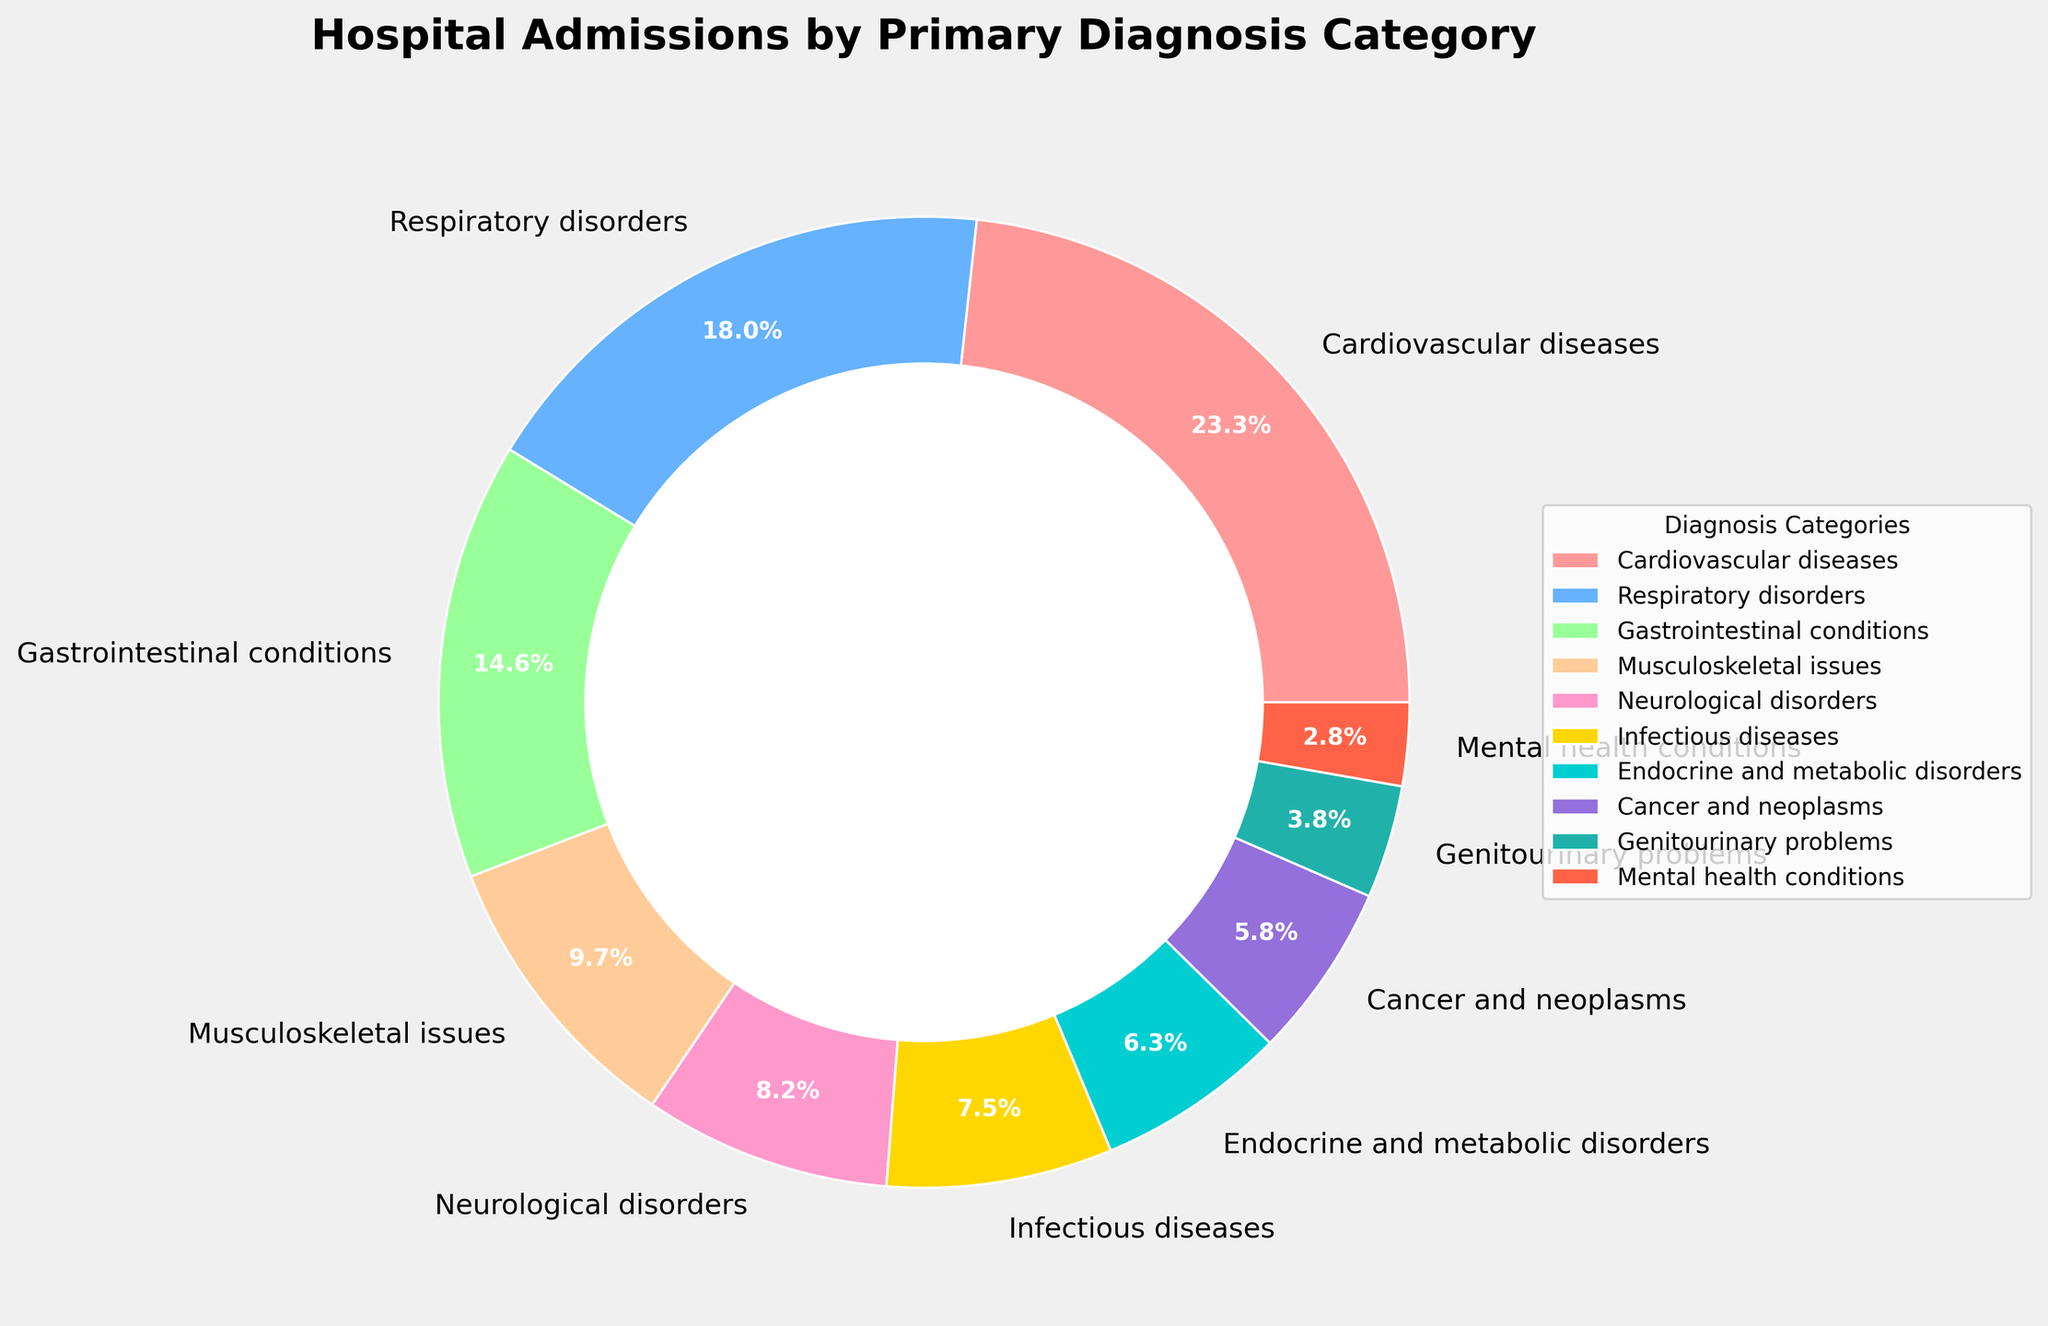Which category has the highest percentage of hospital admissions? The highest percentage is the one with the largest segment in the pie chart. According to the legend, cardiovascular diseases have the largest segment at 23.5%.
Answer: Cardiovascular diseases Which category has a smaller percentage: Mental health conditions or Genitourinary problems? By comparing the segments for Mental health conditions and Genitourinary problems, Mental health conditions have a smaller segment. According to the data, Mental health conditions have 2.8% while Genitourinary problems have 3.8%.
Answer: Mental health conditions How does the percentage of hospital admissions for Respiratory disorders compare to that for Gastrointestinal conditions? By comparing the segments, Respiratory disorders have a larger segment than Gastrointestinal conditions. The percentages are 18.2% for Respiratory disorders and 14.7% for Gastrointestinal conditions.
Answer: Respiratory disorders are higher What is the combined percentage of hospital admissions for Cardiovascular diseases, Neurological disorders, and Cancer and neoplasms? Sum the percentages for these three categories: 23.5% (Cardiovascular diseases) + 8.3% (Neurological disorders) + 5.9% (Cancer and neoplasms) = 37.7%.
Answer: 37.7% Which categories combined make up more than 30% of hospital admissions: Musculoskeletal issues and Infectious diseases, or Endocrine and metabolic disorders and Cancer and neoplasms? Sum the percentages for each pair to determine which exceeds 30%. 
Pair 1: Musculoskeletal issues (9.8%) + Infectious diseases (7.6%) = 17.4%
Pair 2: Endocrine and metabolic disorders (6.4%) + Cancer and neoplasms (5.9%) = 12.3%.
Neither pair exceeds 30%.
Answer: Neither How many categories have less than 10% of the total hospital admissions each? Count the segments where the percentage is less than 10%. These categories are Musculoskeletal issues (9.8%), Neurological disorders (8.3%), Infectious diseases (7.6%), Endocrine and metabolic disorders (6.4%), Cancer and neoplasms (5.9%), Genitourinary problems (3.8%), and Mental health conditions (2.8%). This totals to seven categories.
Answer: 7 What is the percentage difference between the highest and the lowest categories in terms of hospital admissions? Subtract the percentage of the smallest category from the largest. 
Largest: Cardiovascular diseases (23.5%)
Smallest: Mental health conditions (2.8%)
Difference: 23.5% - 2.8% = 20.7%
Answer: 20.7% What is the average percentage of hospital admissions across all categories? Sum all the percentages and divide by the number of categories.
Sum: 23.5 + 18.2 + 14.7 + 9.8 + 8.3 + 7.6 + 6.4 + 5.9 + 3.8 + 2.8 = 101.0 (Note: rounding errors might cause the total to slightly exceed 100)
Number of categories: 10
Average: 101.0 / 10 = 10.1%
Answer: 10.1% 